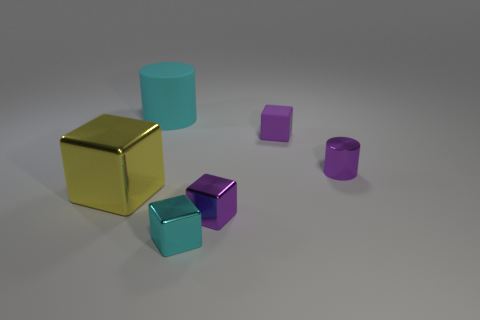Add 2 small red rubber spheres. How many objects exist? 8 Subtract all small cyan metallic blocks. How many blocks are left? 3 Subtract all purple cylinders. How many cylinders are left? 1 Subtract all cylinders. How many objects are left? 4 Subtract 1 blocks. How many blocks are left? 3 Subtract all purple cylinders. Subtract all yellow cubes. How many cylinders are left? 1 Subtract all brown cylinders. How many purple blocks are left? 2 Subtract all tiny purple rubber blocks. Subtract all tiny red matte balls. How many objects are left? 5 Add 5 tiny cylinders. How many tiny cylinders are left? 6 Add 6 small purple cubes. How many small purple cubes exist? 8 